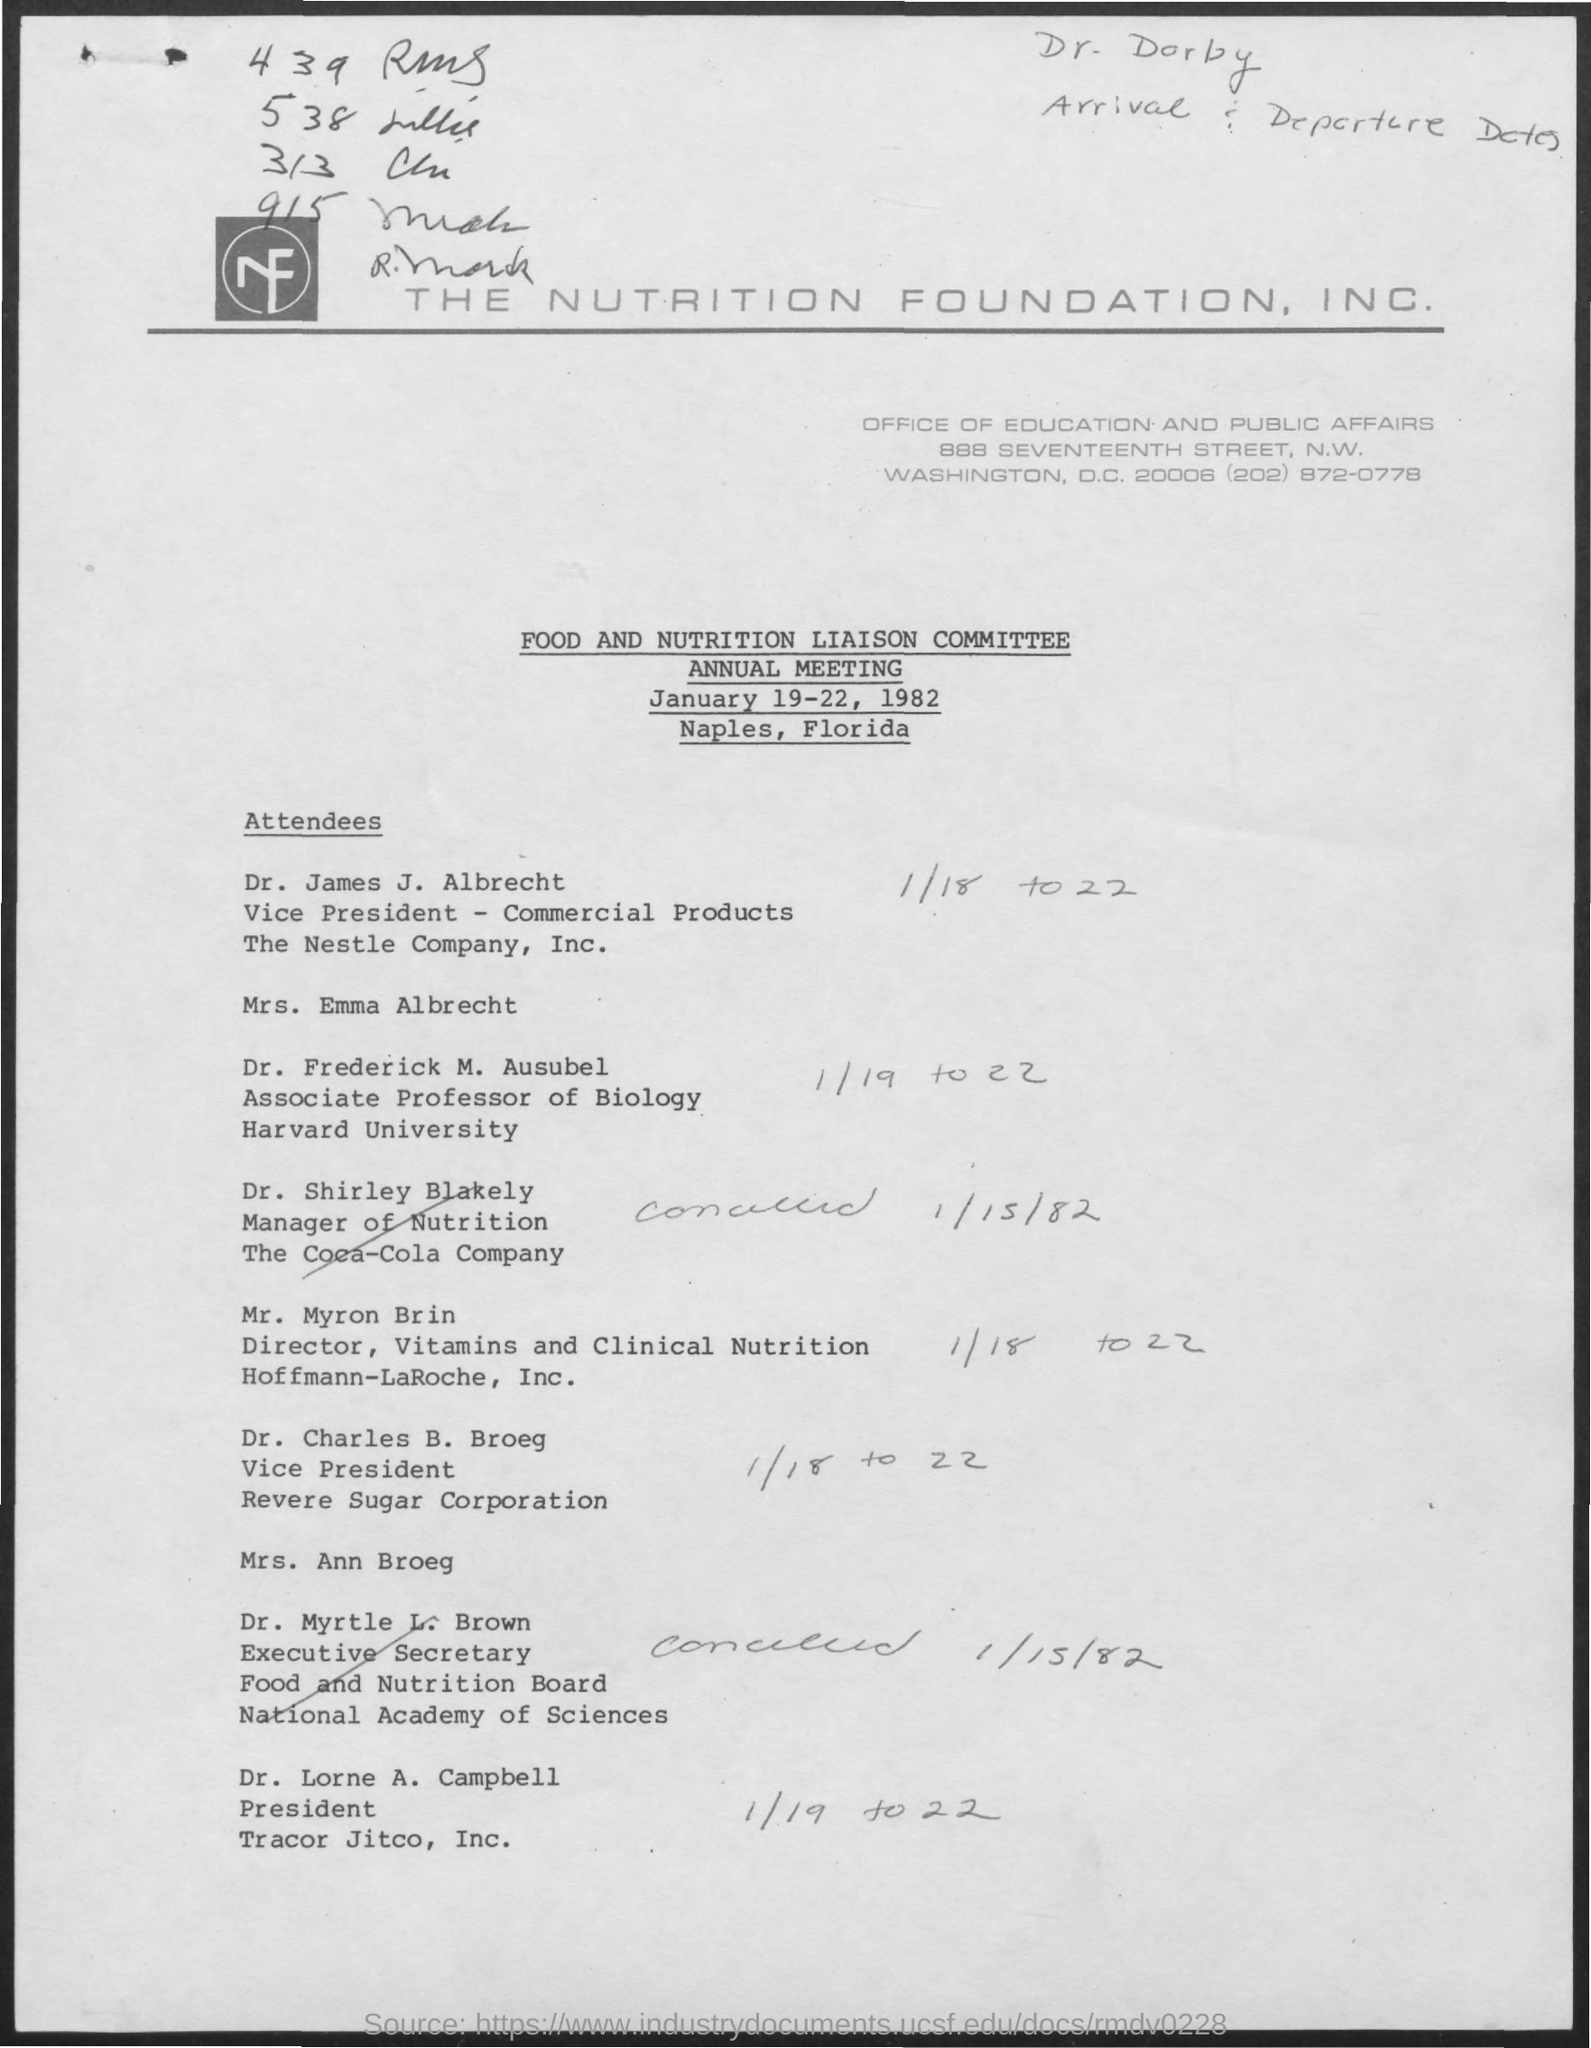Charles B. Broeg is the vice-president of which company?
Ensure brevity in your answer.  Revere Sugar Corporation. Lorne A. Campbell is the president of which company?
Your response must be concise. Tracor Jitco, Inc. Frederick M. Ausubel is an associate professor at which university?
Offer a terse response. Harvard. What is the telephone number mentioned in the document?
Make the answer very short. (202) 872-0778. 